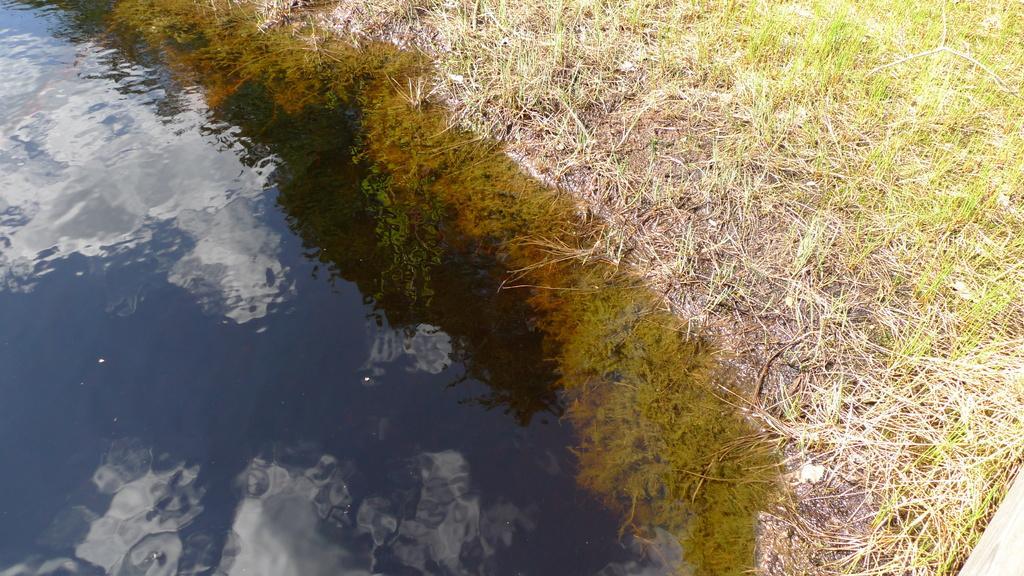Please provide a concise description of this image. In the image I can see water, plants and also I can see the reflection of clouds in the water. 